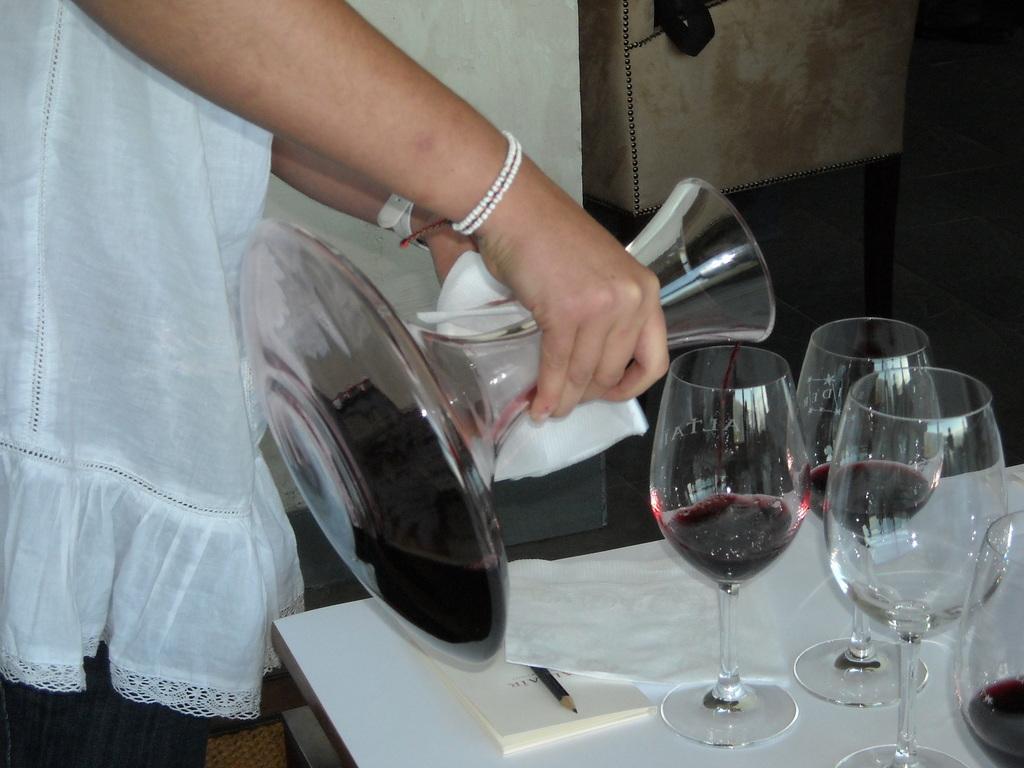Can you describe this image briefly? In the image we can see a person standing, wearing clothes, bracelet and the person is holding a glass object in hand. Here we can see a table, on the table, we can see book, pencil, tissue paper and wine glasses. 